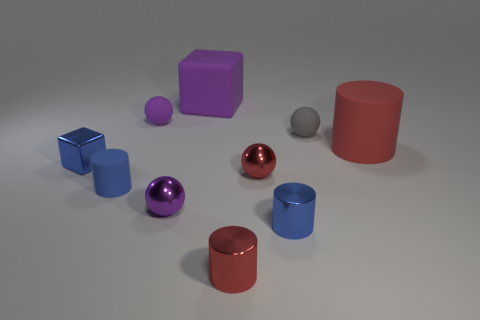Subtract all big cylinders. How many cylinders are left? 3 Subtract all blue shiny blocks. Subtract all large purple cubes. How many objects are left? 8 Add 6 blue things. How many blue things are left? 9 Add 3 tiny metal objects. How many tiny metal objects exist? 8 Subtract all gray spheres. How many spheres are left? 3 Subtract 1 gray balls. How many objects are left? 9 Subtract all cylinders. How many objects are left? 6 Subtract 1 balls. How many balls are left? 3 Subtract all cyan cylinders. Subtract all red balls. How many cylinders are left? 4 Subtract all purple balls. How many brown cubes are left? 0 